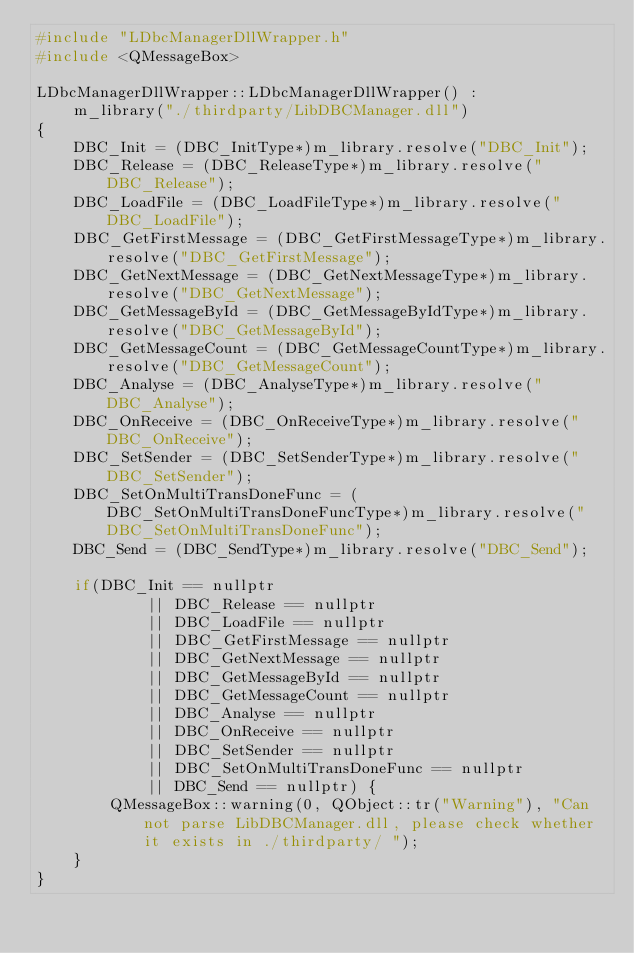Convert code to text. <code><loc_0><loc_0><loc_500><loc_500><_C++_>#include "LDbcManagerDllWrapper.h"
#include <QMessageBox>

LDbcManagerDllWrapper::LDbcManagerDllWrapper() :
    m_library("./thirdparty/LibDBCManager.dll")
{
    DBC_Init = (DBC_InitType*)m_library.resolve("DBC_Init");
    DBC_Release = (DBC_ReleaseType*)m_library.resolve("DBC_Release");
    DBC_LoadFile = (DBC_LoadFileType*)m_library.resolve("DBC_LoadFile");
    DBC_GetFirstMessage = (DBC_GetFirstMessageType*)m_library.resolve("DBC_GetFirstMessage");
    DBC_GetNextMessage = (DBC_GetNextMessageType*)m_library.resolve("DBC_GetNextMessage");
    DBC_GetMessageById = (DBC_GetMessageByIdType*)m_library.resolve("DBC_GetMessageById");
    DBC_GetMessageCount = (DBC_GetMessageCountType*)m_library.resolve("DBC_GetMessageCount");
    DBC_Analyse = (DBC_AnalyseType*)m_library.resolve("DBC_Analyse");
    DBC_OnReceive = (DBC_OnReceiveType*)m_library.resolve("DBC_OnReceive");
    DBC_SetSender = (DBC_SetSenderType*)m_library.resolve("DBC_SetSender");
    DBC_SetOnMultiTransDoneFunc = (DBC_SetOnMultiTransDoneFuncType*)m_library.resolve("DBC_SetOnMultiTransDoneFunc");
    DBC_Send = (DBC_SendType*)m_library.resolve("DBC_Send");

    if(DBC_Init == nullptr
            || DBC_Release == nullptr
            || DBC_LoadFile == nullptr
            || DBC_GetFirstMessage == nullptr
            || DBC_GetNextMessage == nullptr
            || DBC_GetMessageById == nullptr
            || DBC_GetMessageCount == nullptr
            || DBC_Analyse == nullptr
            || DBC_OnReceive == nullptr
            || DBC_SetSender == nullptr
            || DBC_SetOnMultiTransDoneFunc == nullptr
            || DBC_Send == nullptr) {
        QMessageBox::warning(0, QObject::tr("Warning"), "Can not parse LibDBCManager.dll, please check whether it exists in ./thirdparty/ ");
    }
}
</code> 